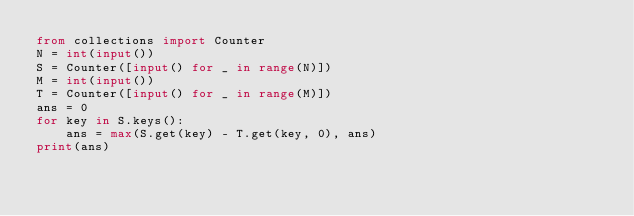Convert code to text. <code><loc_0><loc_0><loc_500><loc_500><_Python_>from collections import Counter
N = int(input())
S = Counter([input() for _ in range(N)])
M = int(input())
T = Counter([input() for _ in range(M)])
ans = 0
for key in S.keys():
    ans = max(S.get(key) - T.get(key, 0), ans)
print(ans)
</code> 